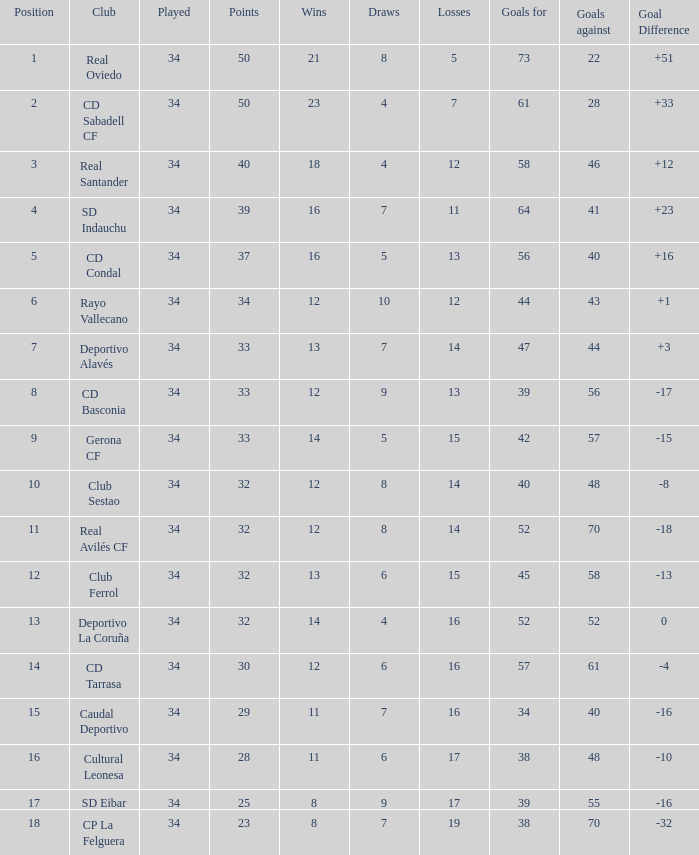For the sd indauchu club, which successful games have a goal difference of more than 0, over 40 goals against, a position within the top 5, and a win? 16.0. 